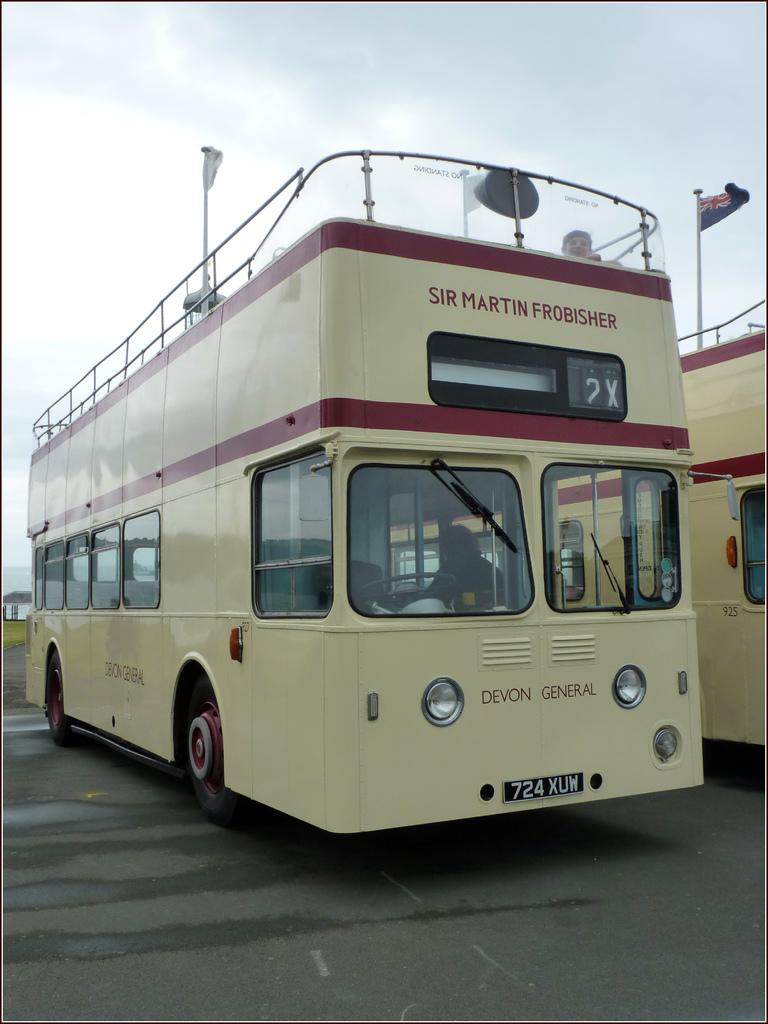What type of vehicles are on the ground in the image? There are buses on the ground in the image. Can you describe any specific features of the buses? There is writing on a bus in the image. Where is the writing located on the bus? The writing is on the left side of the bus. What can be seen in the background of the image? The sky is visible in the background of the image. What type of prose can be heard coming from the bus in the image? There is no indication of any prose or sound coming from the bus in the image. Can you see any hooks attached to the bus in the image? There are no hooks visible on the bus in the image. 